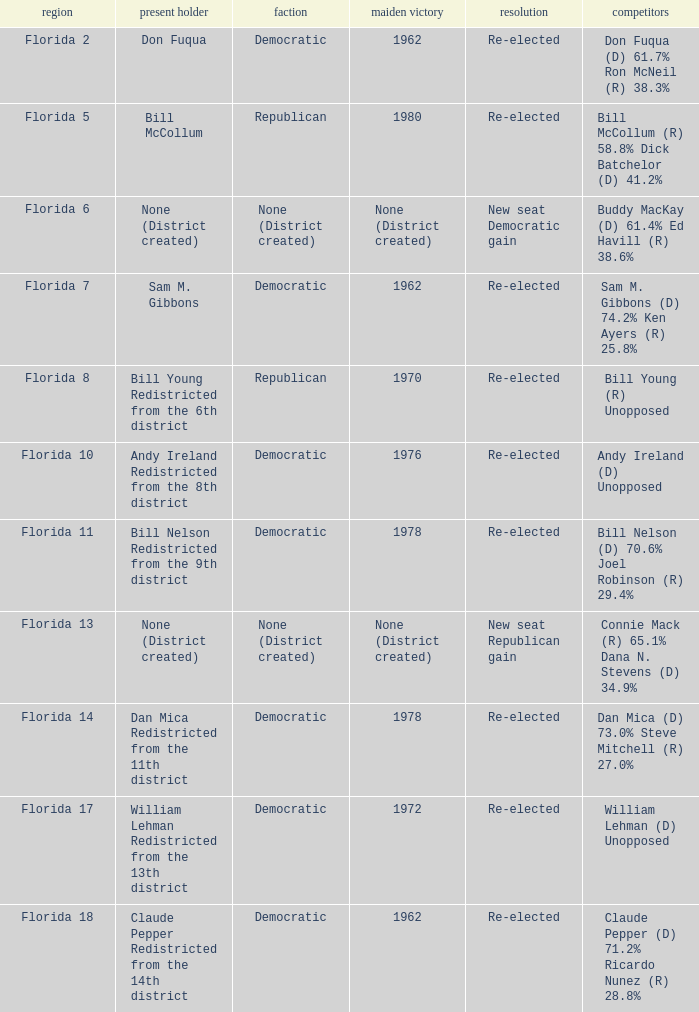What's the district with result being new seat democratic gain Florida 6. 